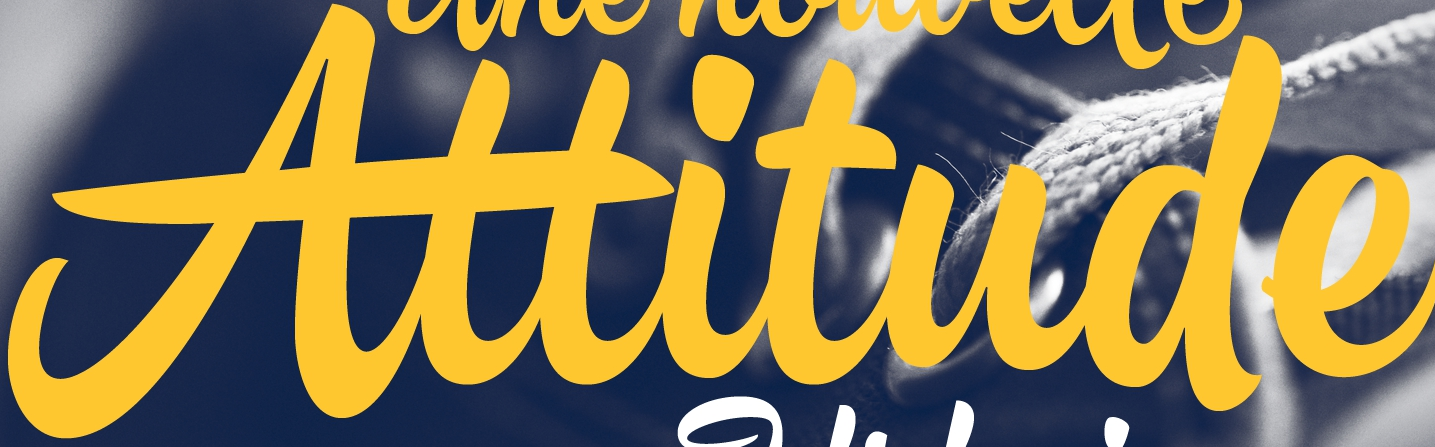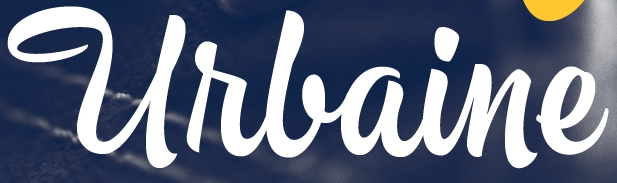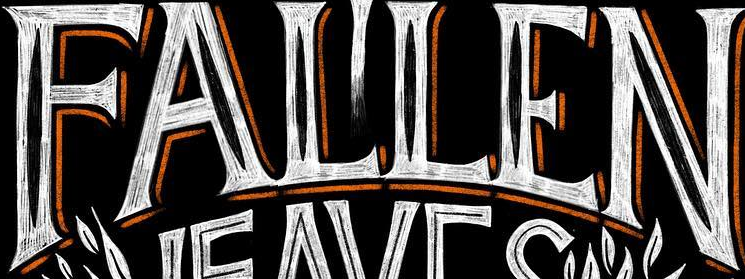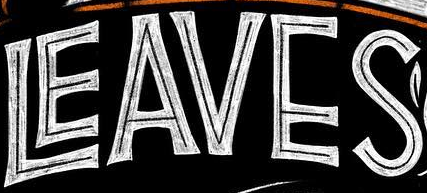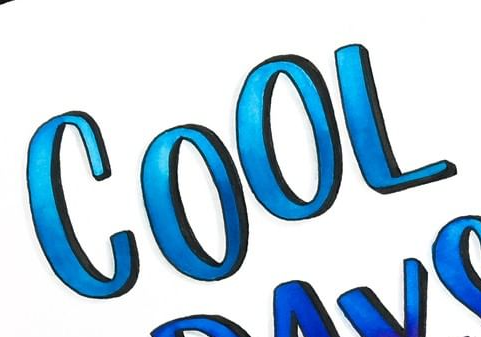What words are shown in these images in order, separated by a semicolon? Attitude; Urlaine; FALLEN; LEAVES; COOL 